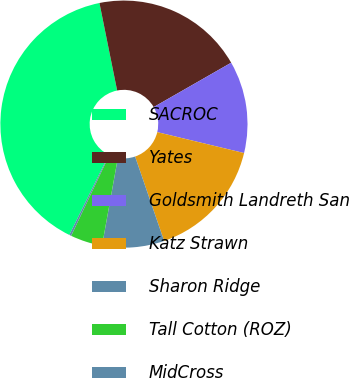Convert chart to OTSL. <chart><loc_0><loc_0><loc_500><loc_500><pie_chart><fcel>SACROC<fcel>Yates<fcel>Goldsmith Landreth San<fcel>Katz Strawn<fcel>Sharon Ridge<fcel>Tall Cotton (ROZ)<fcel>MidCross<nl><fcel>39.54%<fcel>19.9%<fcel>12.04%<fcel>15.97%<fcel>8.11%<fcel>4.19%<fcel>0.26%<nl></chart> 